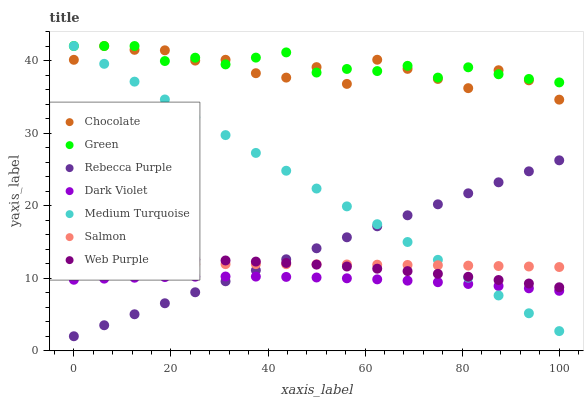Does Dark Violet have the minimum area under the curve?
Answer yes or no. Yes. Does Green have the maximum area under the curve?
Answer yes or no. Yes. Does Chocolate have the minimum area under the curve?
Answer yes or no. No. Does Chocolate have the maximum area under the curve?
Answer yes or no. No. Is Rebecca Purple the smoothest?
Answer yes or no. Yes. Is Chocolate the roughest?
Answer yes or no. Yes. Is Dark Violet the smoothest?
Answer yes or no. No. Is Dark Violet the roughest?
Answer yes or no. No. Does Rebecca Purple have the lowest value?
Answer yes or no. Yes. Does Dark Violet have the lowest value?
Answer yes or no. No. Does Medium Turquoise have the highest value?
Answer yes or no. Yes. Does Dark Violet have the highest value?
Answer yes or no. No. Is Salmon less than Green?
Answer yes or no. Yes. Is Chocolate greater than Web Purple?
Answer yes or no. Yes. Does Medium Turquoise intersect Salmon?
Answer yes or no. Yes. Is Medium Turquoise less than Salmon?
Answer yes or no. No. Is Medium Turquoise greater than Salmon?
Answer yes or no. No. Does Salmon intersect Green?
Answer yes or no. No. 